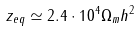<formula> <loc_0><loc_0><loc_500><loc_500>z _ { e q } \simeq 2 . 4 \cdot 1 0 ^ { 4 } \Omega _ { m } h ^ { 2 }</formula> 